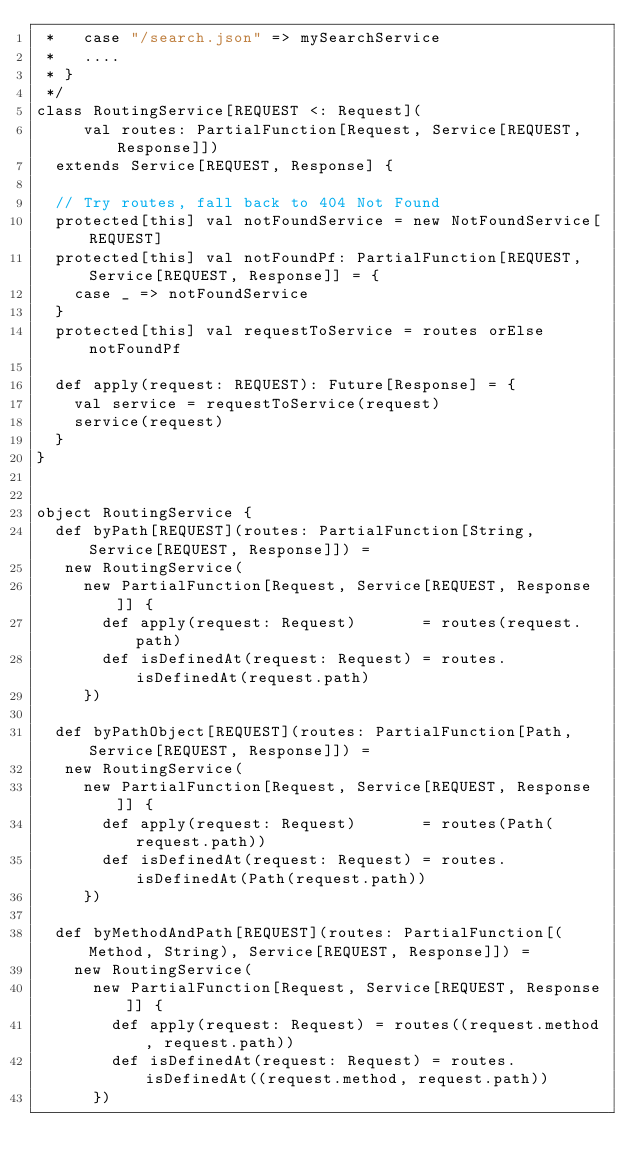<code> <loc_0><loc_0><loc_500><loc_500><_Scala_> *   case "/search.json" => mySearchService
 *   ....
 * }
 */
class RoutingService[REQUEST <: Request](
     val routes: PartialFunction[Request, Service[REQUEST, Response]])
  extends Service[REQUEST, Response] {

  // Try routes, fall back to 404 Not Found
  protected[this] val notFoundService = new NotFoundService[REQUEST]
  protected[this] val notFoundPf: PartialFunction[REQUEST, Service[REQUEST, Response]] = {
    case _ => notFoundService
  }
  protected[this] val requestToService = routes orElse notFoundPf

  def apply(request: REQUEST): Future[Response] = {
    val service = requestToService(request)
    service(request)
  }
}


object RoutingService {
  def byPath[REQUEST](routes: PartialFunction[String, Service[REQUEST, Response]]) =
   new RoutingService(
     new PartialFunction[Request, Service[REQUEST, Response]] {
       def apply(request: Request)       = routes(request.path)
       def isDefinedAt(request: Request) = routes.isDefinedAt(request.path)
     })

  def byPathObject[REQUEST](routes: PartialFunction[Path, Service[REQUEST, Response]]) =
   new RoutingService(
     new PartialFunction[Request, Service[REQUEST, Response]] {
       def apply(request: Request)       = routes(Path(request.path))
       def isDefinedAt(request: Request) = routes.isDefinedAt(Path(request.path))
     })

  def byMethodAndPath[REQUEST](routes: PartialFunction[(Method, String), Service[REQUEST, Response]]) =
    new RoutingService(
      new PartialFunction[Request, Service[REQUEST, Response]] {
        def apply(request: Request) = routes((request.method, request.path))
        def isDefinedAt(request: Request) = routes.isDefinedAt((request.method, request.path))
      })
</code> 